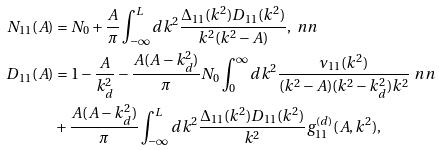Convert formula to latex. <formula><loc_0><loc_0><loc_500><loc_500>N _ { 1 1 } ( A ) & = N _ { 0 } + \frac { A } { \pi } \int _ { - \infty } ^ { L } d k ^ { 2 } \frac { \Delta _ { 1 1 } ( k ^ { 2 } ) D _ { 1 1 } ( k ^ { 2 } ) } { k ^ { 2 } ( k ^ { 2 } - A ) } , \ n n \\ D _ { 1 1 } ( A ) & = 1 - \frac { A } { k _ { d } ^ { 2 } } - \frac { A ( A - k _ { d } ^ { 2 } ) } { \pi } N _ { 0 } \int _ { 0 } ^ { \infty } d k ^ { 2 } \frac { \nu _ { 1 1 } ( k ^ { 2 } ) } { ( k ^ { 2 } - A ) ( k ^ { 2 } - k _ { d } ^ { 2 } ) k ^ { 2 } } \ n n \\ & + \frac { A ( A - k _ { d } ^ { 2 } ) } { \pi } \int _ { - \infty } ^ { L } d k ^ { 2 } \frac { \Delta _ { 1 1 } ( k ^ { 2 } ) D _ { 1 1 } ( k ^ { 2 } ) } { k ^ { 2 } } g _ { 1 1 } ^ { ( d ) } ( A , k ^ { 2 } ) ,</formula> 